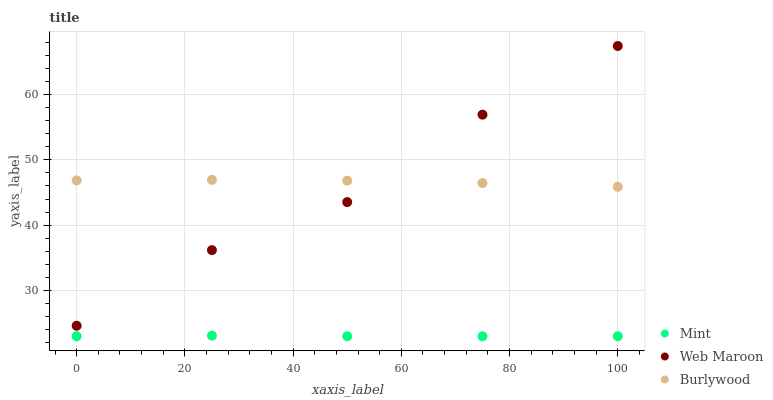Does Mint have the minimum area under the curve?
Answer yes or no. Yes. Does Burlywood have the maximum area under the curve?
Answer yes or no. Yes. Does Web Maroon have the minimum area under the curve?
Answer yes or no. No. Does Web Maroon have the maximum area under the curve?
Answer yes or no. No. Is Mint the smoothest?
Answer yes or no. Yes. Is Web Maroon the roughest?
Answer yes or no. Yes. Is Web Maroon the smoothest?
Answer yes or no. No. Is Mint the roughest?
Answer yes or no. No. Does Mint have the lowest value?
Answer yes or no. Yes. Does Web Maroon have the lowest value?
Answer yes or no. No. Does Web Maroon have the highest value?
Answer yes or no. Yes. Does Mint have the highest value?
Answer yes or no. No. Is Mint less than Web Maroon?
Answer yes or no. Yes. Is Burlywood greater than Mint?
Answer yes or no. Yes. Does Burlywood intersect Web Maroon?
Answer yes or no. Yes. Is Burlywood less than Web Maroon?
Answer yes or no. No. Is Burlywood greater than Web Maroon?
Answer yes or no. No. Does Mint intersect Web Maroon?
Answer yes or no. No. 